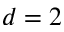<formula> <loc_0><loc_0><loc_500><loc_500>d = 2</formula> 